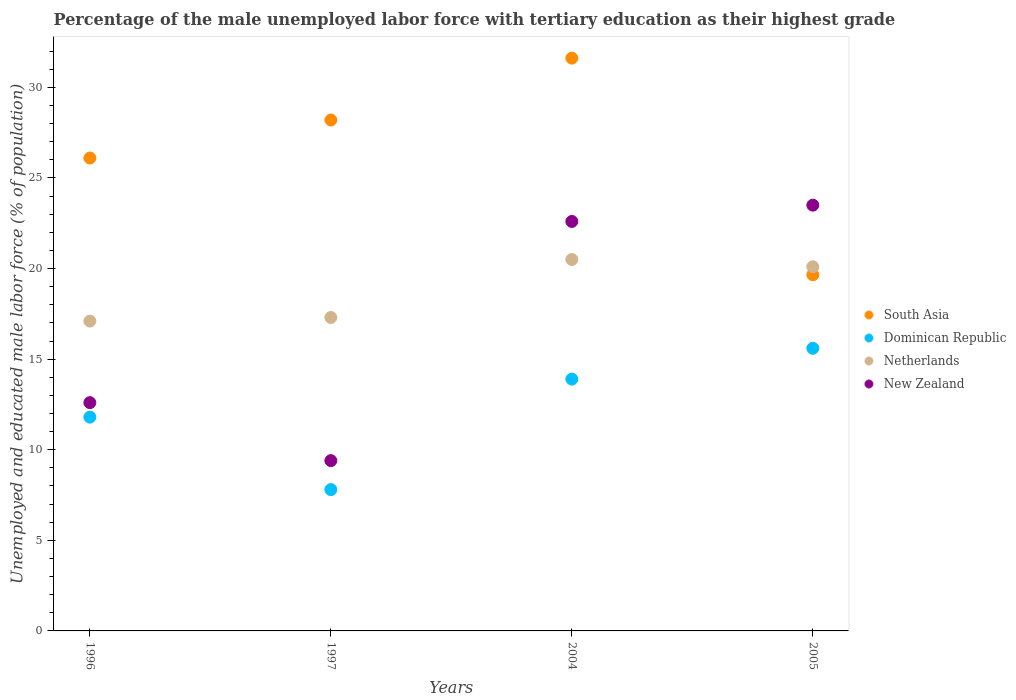Is the number of dotlines equal to the number of legend labels?
Keep it short and to the point. Yes. What is the percentage of the unemployed male labor force with tertiary education in Netherlands in 1997?
Keep it short and to the point. 17.3. Across all years, what is the maximum percentage of the unemployed male labor force with tertiary education in New Zealand?
Keep it short and to the point. 23.5. Across all years, what is the minimum percentage of the unemployed male labor force with tertiary education in South Asia?
Your answer should be very brief. 19.66. What is the total percentage of the unemployed male labor force with tertiary education in South Asia in the graph?
Offer a terse response. 105.57. What is the difference between the percentage of the unemployed male labor force with tertiary education in New Zealand in 2004 and that in 2005?
Ensure brevity in your answer.  -0.9. What is the difference between the percentage of the unemployed male labor force with tertiary education in South Asia in 1997 and the percentage of the unemployed male labor force with tertiary education in Dominican Republic in 2005?
Ensure brevity in your answer.  12.6. What is the average percentage of the unemployed male labor force with tertiary education in Netherlands per year?
Make the answer very short. 18.75. In the year 2004, what is the difference between the percentage of the unemployed male labor force with tertiary education in Netherlands and percentage of the unemployed male labor force with tertiary education in South Asia?
Your answer should be compact. -11.11. In how many years, is the percentage of the unemployed male labor force with tertiary education in Dominican Republic greater than 18 %?
Provide a succinct answer. 0. What is the ratio of the percentage of the unemployed male labor force with tertiary education in Netherlands in 1996 to that in 1997?
Keep it short and to the point. 0.99. Is the percentage of the unemployed male labor force with tertiary education in Netherlands in 1996 less than that in 2004?
Provide a short and direct response. Yes. What is the difference between the highest and the second highest percentage of the unemployed male labor force with tertiary education in New Zealand?
Make the answer very short. 0.9. What is the difference between the highest and the lowest percentage of the unemployed male labor force with tertiary education in Netherlands?
Make the answer very short. 3.4. In how many years, is the percentage of the unemployed male labor force with tertiary education in South Asia greater than the average percentage of the unemployed male labor force with tertiary education in South Asia taken over all years?
Offer a terse response. 2. Is the sum of the percentage of the unemployed male labor force with tertiary education in Netherlands in 1996 and 2004 greater than the maximum percentage of the unemployed male labor force with tertiary education in New Zealand across all years?
Keep it short and to the point. Yes. Does the percentage of the unemployed male labor force with tertiary education in South Asia monotonically increase over the years?
Your response must be concise. No. Is the percentage of the unemployed male labor force with tertiary education in South Asia strictly less than the percentage of the unemployed male labor force with tertiary education in Dominican Republic over the years?
Give a very brief answer. No. How many years are there in the graph?
Give a very brief answer. 4. What is the difference between two consecutive major ticks on the Y-axis?
Offer a terse response. 5. Does the graph contain any zero values?
Ensure brevity in your answer.  No. Does the graph contain grids?
Provide a succinct answer. No. Where does the legend appear in the graph?
Provide a succinct answer. Center right. How many legend labels are there?
Make the answer very short. 4. What is the title of the graph?
Provide a succinct answer. Percentage of the male unemployed labor force with tertiary education as their highest grade. Does "Mauritius" appear as one of the legend labels in the graph?
Give a very brief answer. No. What is the label or title of the X-axis?
Offer a terse response. Years. What is the label or title of the Y-axis?
Give a very brief answer. Unemployed and educated male labor force (% of population). What is the Unemployed and educated male labor force (% of population) in South Asia in 1996?
Ensure brevity in your answer.  26.1. What is the Unemployed and educated male labor force (% of population) in Dominican Republic in 1996?
Your answer should be compact. 11.8. What is the Unemployed and educated male labor force (% of population) of Netherlands in 1996?
Your answer should be very brief. 17.1. What is the Unemployed and educated male labor force (% of population) of New Zealand in 1996?
Offer a very short reply. 12.6. What is the Unemployed and educated male labor force (% of population) of South Asia in 1997?
Keep it short and to the point. 28.2. What is the Unemployed and educated male labor force (% of population) of Dominican Republic in 1997?
Ensure brevity in your answer.  7.8. What is the Unemployed and educated male labor force (% of population) in Netherlands in 1997?
Offer a very short reply. 17.3. What is the Unemployed and educated male labor force (% of population) in New Zealand in 1997?
Ensure brevity in your answer.  9.4. What is the Unemployed and educated male labor force (% of population) of South Asia in 2004?
Provide a succinct answer. 31.61. What is the Unemployed and educated male labor force (% of population) of Dominican Republic in 2004?
Provide a succinct answer. 13.9. What is the Unemployed and educated male labor force (% of population) in Netherlands in 2004?
Keep it short and to the point. 20.5. What is the Unemployed and educated male labor force (% of population) of New Zealand in 2004?
Ensure brevity in your answer.  22.6. What is the Unemployed and educated male labor force (% of population) in South Asia in 2005?
Ensure brevity in your answer.  19.66. What is the Unemployed and educated male labor force (% of population) in Dominican Republic in 2005?
Ensure brevity in your answer.  15.6. What is the Unemployed and educated male labor force (% of population) in Netherlands in 2005?
Make the answer very short. 20.1. Across all years, what is the maximum Unemployed and educated male labor force (% of population) in South Asia?
Give a very brief answer. 31.61. Across all years, what is the maximum Unemployed and educated male labor force (% of population) in Dominican Republic?
Ensure brevity in your answer.  15.6. Across all years, what is the maximum Unemployed and educated male labor force (% of population) of Netherlands?
Your response must be concise. 20.5. Across all years, what is the maximum Unemployed and educated male labor force (% of population) of New Zealand?
Offer a terse response. 23.5. Across all years, what is the minimum Unemployed and educated male labor force (% of population) of South Asia?
Ensure brevity in your answer.  19.66. Across all years, what is the minimum Unemployed and educated male labor force (% of population) in Dominican Republic?
Your answer should be compact. 7.8. Across all years, what is the minimum Unemployed and educated male labor force (% of population) in Netherlands?
Your answer should be compact. 17.1. Across all years, what is the minimum Unemployed and educated male labor force (% of population) in New Zealand?
Provide a succinct answer. 9.4. What is the total Unemployed and educated male labor force (% of population) of South Asia in the graph?
Make the answer very short. 105.57. What is the total Unemployed and educated male labor force (% of population) in Dominican Republic in the graph?
Your response must be concise. 49.1. What is the total Unemployed and educated male labor force (% of population) in New Zealand in the graph?
Provide a short and direct response. 68.1. What is the difference between the Unemployed and educated male labor force (% of population) of South Asia in 1996 and that in 1997?
Offer a very short reply. -2.1. What is the difference between the Unemployed and educated male labor force (% of population) of Dominican Republic in 1996 and that in 1997?
Give a very brief answer. 4. What is the difference between the Unemployed and educated male labor force (% of population) of Netherlands in 1996 and that in 1997?
Make the answer very short. -0.2. What is the difference between the Unemployed and educated male labor force (% of population) in New Zealand in 1996 and that in 1997?
Offer a terse response. 3.2. What is the difference between the Unemployed and educated male labor force (% of population) in South Asia in 1996 and that in 2004?
Your answer should be very brief. -5.51. What is the difference between the Unemployed and educated male labor force (% of population) of Dominican Republic in 1996 and that in 2004?
Offer a terse response. -2.1. What is the difference between the Unemployed and educated male labor force (% of population) of Netherlands in 1996 and that in 2004?
Offer a terse response. -3.4. What is the difference between the Unemployed and educated male labor force (% of population) of New Zealand in 1996 and that in 2004?
Your response must be concise. -10. What is the difference between the Unemployed and educated male labor force (% of population) of South Asia in 1996 and that in 2005?
Provide a short and direct response. 6.44. What is the difference between the Unemployed and educated male labor force (% of population) of Dominican Republic in 1996 and that in 2005?
Ensure brevity in your answer.  -3.8. What is the difference between the Unemployed and educated male labor force (% of population) of South Asia in 1997 and that in 2004?
Provide a short and direct response. -3.41. What is the difference between the Unemployed and educated male labor force (% of population) in South Asia in 1997 and that in 2005?
Your response must be concise. 8.54. What is the difference between the Unemployed and educated male labor force (% of population) in Dominican Republic in 1997 and that in 2005?
Ensure brevity in your answer.  -7.8. What is the difference between the Unemployed and educated male labor force (% of population) in Netherlands in 1997 and that in 2005?
Keep it short and to the point. -2.8. What is the difference between the Unemployed and educated male labor force (% of population) in New Zealand in 1997 and that in 2005?
Your response must be concise. -14.1. What is the difference between the Unemployed and educated male labor force (% of population) in South Asia in 2004 and that in 2005?
Offer a very short reply. 11.96. What is the difference between the Unemployed and educated male labor force (% of population) of New Zealand in 2004 and that in 2005?
Your response must be concise. -0.9. What is the difference between the Unemployed and educated male labor force (% of population) in South Asia in 1996 and the Unemployed and educated male labor force (% of population) in Dominican Republic in 1997?
Keep it short and to the point. 18.3. What is the difference between the Unemployed and educated male labor force (% of population) of South Asia in 1996 and the Unemployed and educated male labor force (% of population) of Netherlands in 1997?
Your response must be concise. 8.8. What is the difference between the Unemployed and educated male labor force (% of population) of South Asia in 1996 and the Unemployed and educated male labor force (% of population) of New Zealand in 1997?
Offer a terse response. 16.7. What is the difference between the Unemployed and educated male labor force (% of population) of Dominican Republic in 1996 and the Unemployed and educated male labor force (% of population) of New Zealand in 1997?
Provide a short and direct response. 2.4. What is the difference between the Unemployed and educated male labor force (% of population) of Netherlands in 1996 and the Unemployed and educated male labor force (% of population) of New Zealand in 1997?
Your answer should be compact. 7.7. What is the difference between the Unemployed and educated male labor force (% of population) of South Asia in 1996 and the Unemployed and educated male labor force (% of population) of Dominican Republic in 2004?
Make the answer very short. 12.2. What is the difference between the Unemployed and educated male labor force (% of population) in South Asia in 1996 and the Unemployed and educated male labor force (% of population) in Netherlands in 2004?
Ensure brevity in your answer.  5.6. What is the difference between the Unemployed and educated male labor force (% of population) in South Asia in 1996 and the Unemployed and educated male labor force (% of population) in New Zealand in 2004?
Give a very brief answer. 3.5. What is the difference between the Unemployed and educated male labor force (% of population) of Dominican Republic in 1996 and the Unemployed and educated male labor force (% of population) of New Zealand in 2004?
Give a very brief answer. -10.8. What is the difference between the Unemployed and educated male labor force (% of population) of Netherlands in 1996 and the Unemployed and educated male labor force (% of population) of New Zealand in 2004?
Offer a terse response. -5.5. What is the difference between the Unemployed and educated male labor force (% of population) in South Asia in 1996 and the Unemployed and educated male labor force (% of population) in Dominican Republic in 2005?
Offer a terse response. 10.5. What is the difference between the Unemployed and educated male labor force (% of population) in South Asia in 1996 and the Unemployed and educated male labor force (% of population) in Netherlands in 2005?
Ensure brevity in your answer.  6. What is the difference between the Unemployed and educated male labor force (% of population) of South Asia in 1996 and the Unemployed and educated male labor force (% of population) of New Zealand in 2005?
Provide a succinct answer. 2.6. What is the difference between the Unemployed and educated male labor force (% of population) in Dominican Republic in 1996 and the Unemployed and educated male labor force (% of population) in New Zealand in 2005?
Your answer should be very brief. -11.7. What is the difference between the Unemployed and educated male labor force (% of population) in Netherlands in 1996 and the Unemployed and educated male labor force (% of population) in New Zealand in 2005?
Your response must be concise. -6.4. What is the difference between the Unemployed and educated male labor force (% of population) in South Asia in 1997 and the Unemployed and educated male labor force (% of population) in Netherlands in 2004?
Offer a terse response. 7.7. What is the difference between the Unemployed and educated male labor force (% of population) of South Asia in 1997 and the Unemployed and educated male labor force (% of population) of New Zealand in 2004?
Your answer should be very brief. 5.6. What is the difference between the Unemployed and educated male labor force (% of population) of Dominican Republic in 1997 and the Unemployed and educated male labor force (% of population) of New Zealand in 2004?
Provide a short and direct response. -14.8. What is the difference between the Unemployed and educated male labor force (% of population) in Netherlands in 1997 and the Unemployed and educated male labor force (% of population) in New Zealand in 2004?
Keep it short and to the point. -5.3. What is the difference between the Unemployed and educated male labor force (% of population) in South Asia in 1997 and the Unemployed and educated male labor force (% of population) in Dominican Republic in 2005?
Provide a succinct answer. 12.6. What is the difference between the Unemployed and educated male labor force (% of population) in Dominican Republic in 1997 and the Unemployed and educated male labor force (% of population) in New Zealand in 2005?
Your answer should be very brief. -15.7. What is the difference between the Unemployed and educated male labor force (% of population) in Netherlands in 1997 and the Unemployed and educated male labor force (% of population) in New Zealand in 2005?
Provide a succinct answer. -6.2. What is the difference between the Unemployed and educated male labor force (% of population) in South Asia in 2004 and the Unemployed and educated male labor force (% of population) in Dominican Republic in 2005?
Provide a short and direct response. 16.01. What is the difference between the Unemployed and educated male labor force (% of population) of South Asia in 2004 and the Unemployed and educated male labor force (% of population) of Netherlands in 2005?
Ensure brevity in your answer.  11.51. What is the difference between the Unemployed and educated male labor force (% of population) in South Asia in 2004 and the Unemployed and educated male labor force (% of population) in New Zealand in 2005?
Offer a very short reply. 8.11. What is the difference between the Unemployed and educated male labor force (% of population) of Dominican Republic in 2004 and the Unemployed and educated male labor force (% of population) of Netherlands in 2005?
Ensure brevity in your answer.  -6.2. What is the difference between the Unemployed and educated male labor force (% of population) in Dominican Republic in 2004 and the Unemployed and educated male labor force (% of population) in New Zealand in 2005?
Your answer should be very brief. -9.6. What is the difference between the Unemployed and educated male labor force (% of population) of Netherlands in 2004 and the Unemployed and educated male labor force (% of population) of New Zealand in 2005?
Your answer should be compact. -3. What is the average Unemployed and educated male labor force (% of population) of South Asia per year?
Make the answer very short. 26.39. What is the average Unemployed and educated male labor force (% of population) in Dominican Republic per year?
Keep it short and to the point. 12.28. What is the average Unemployed and educated male labor force (% of population) in Netherlands per year?
Your answer should be very brief. 18.75. What is the average Unemployed and educated male labor force (% of population) in New Zealand per year?
Your response must be concise. 17.02. In the year 1996, what is the difference between the Unemployed and educated male labor force (% of population) of South Asia and Unemployed and educated male labor force (% of population) of Dominican Republic?
Ensure brevity in your answer.  14.3. In the year 1996, what is the difference between the Unemployed and educated male labor force (% of population) in South Asia and Unemployed and educated male labor force (% of population) in Netherlands?
Keep it short and to the point. 9. In the year 1996, what is the difference between the Unemployed and educated male labor force (% of population) of South Asia and Unemployed and educated male labor force (% of population) of New Zealand?
Your response must be concise. 13.5. In the year 1996, what is the difference between the Unemployed and educated male labor force (% of population) in Dominican Republic and Unemployed and educated male labor force (% of population) in Netherlands?
Your answer should be compact. -5.3. In the year 1996, what is the difference between the Unemployed and educated male labor force (% of population) of Netherlands and Unemployed and educated male labor force (% of population) of New Zealand?
Your answer should be very brief. 4.5. In the year 1997, what is the difference between the Unemployed and educated male labor force (% of population) in South Asia and Unemployed and educated male labor force (% of population) in Dominican Republic?
Your answer should be compact. 20.4. In the year 1997, what is the difference between the Unemployed and educated male labor force (% of population) of Dominican Republic and Unemployed and educated male labor force (% of population) of New Zealand?
Your answer should be very brief. -1.6. In the year 2004, what is the difference between the Unemployed and educated male labor force (% of population) of South Asia and Unemployed and educated male labor force (% of population) of Dominican Republic?
Your answer should be compact. 17.71. In the year 2004, what is the difference between the Unemployed and educated male labor force (% of population) of South Asia and Unemployed and educated male labor force (% of population) of Netherlands?
Keep it short and to the point. 11.11. In the year 2004, what is the difference between the Unemployed and educated male labor force (% of population) in South Asia and Unemployed and educated male labor force (% of population) in New Zealand?
Provide a succinct answer. 9.01. In the year 2005, what is the difference between the Unemployed and educated male labor force (% of population) in South Asia and Unemployed and educated male labor force (% of population) in Dominican Republic?
Your response must be concise. 4.06. In the year 2005, what is the difference between the Unemployed and educated male labor force (% of population) in South Asia and Unemployed and educated male labor force (% of population) in Netherlands?
Offer a very short reply. -0.44. In the year 2005, what is the difference between the Unemployed and educated male labor force (% of population) of South Asia and Unemployed and educated male labor force (% of population) of New Zealand?
Offer a very short reply. -3.84. In the year 2005, what is the difference between the Unemployed and educated male labor force (% of population) in Dominican Republic and Unemployed and educated male labor force (% of population) in Netherlands?
Ensure brevity in your answer.  -4.5. What is the ratio of the Unemployed and educated male labor force (% of population) in South Asia in 1996 to that in 1997?
Give a very brief answer. 0.93. What is the ratio of the Unemployed and educated male labor force (% of population) in Dominican Republic in 1996 to that in 1997?
Ensure brevity in your answer.  1.51. What is the ratio of the Unemployed and educated male labor force (% of population) in Netherlands in 1996 to that in 1997?
Ensure brevity in your answer.  0.99. What is the ratio of the Unemployed and educated male labor force (% of population) in New Zealand in 1996 to that in 1997?
Ensure brevity in your answer.  1.34. What is the ratio of the Unemployed and educated male labor force (% of population) of South Asia in 1996 to that in 2004?
Provide a succinct answer. 0.83. What is the ratio of the Unemployed and educated male labor force (% of population) in Dominican Republic in 1996 to that in 2004?
Offer a very short reply. 0.85. What is the ratio of the Unemployed and educated male labor force (% of population) of Netherlands in 1996 to that in 2004?
Your response must be concise. 0.83. What is the ratio of the Unemployed and educated male labor force (% of population) of New Zealand in 1996 to that in 2004?
Your answer should be very brief. 0.56. What is the ratio of the Unemployed and educated male labor force (% of population) of South Asia in 1996 to that in 2005?
Your response must be concise. 1.33. What is the ratio of the Unemployed and educated male labor force (% of population) of Dominican Republic in 1996 to that in 2005?
Ensure brevity in your answer.  0.76. What is the ratio of the Unemployed and educated male labor force (% of population) in Netherlands in 1996 to that in 2005?
Your response must be concise. 0.85. What is the ratio of the Unemployed and educated male labor force (% of population) in New Zealand in 1996 to that in 2005?
Make the answer very short. 0.54. What is the ratio of the Unemployed and educated male labor force (% of population) in South Asia in 1997 to that in 2004?
Provide a succinct answer. 0.89. What is the ratio of the Unemployed and educated male labor force (% of population) of Dominican Republic in 1997 to that in 2004?
Your answer should be very brief. 0.56. What is the ratio of the Unemployed and educated male labor force (% of population) of Netherlands in 1997 to that in 2004?
Provide a short and direct response. 0.84. What is the ratio of the Unemployed and educated male labor force (% of population) of New Zealand in 1997 to that in 2004?
Provide a short and direct response. 0.42. What is the ratio of the Unemployed and educated male labor force (% of population) of South Asia in 1997 to that in 2005?
Give a very brief answer. 1.43. What is the ratio of the Unemployed and educated male labor force (% of population) of Netherlands in 1997 to that in 2005?
Keep it short and to the point. 0.86. What is the ratio of the Unemployed and educated male labor force (% of population) in New Zealand in 1997 to that in 2005?
Provide a short and direct response. 0.4. What is the ratio of the Unemployed and educated male labor force (% of population) of South Asia in 2004 to that in 2005?
Give a very brief answer. 1.61. What is the ratio of the Unemployed and educated male labor force (% of population) of Dominican Republic in 2004 to that in 2005?
Keep it short and to the point. 0.89. What is the ratio of the Unemployed and educated male labor force (% of population) in Netherlands in 2004 to that in 2005?
Provide a succinct answer. 1.02. What is the ratio of the Unemployed and educated male labor force (% of population) of New Zealand in 2004 to that in 2005?
Provide a short and direct response. 0.96. What is the difference between the highest and the second highest Unemployed and educated male labor force (% of population) of South Asia?
Make the answer very short. 3.41. What is the difference between the highest and the second highest Unemployed and educated male labor force (% of population) of Dominican Republic?
Provide a short and direct response. 1.7. What is the difference between the highest and the second highest Unemployed and educated male labor force (% of population) of Netherlands?
Provide a short and direct response. 0.4. What is the difference between the highest and the lowest Unemployed and educated male labor force (% of population) in South Asia?
Provide a short and direct response. 11.96. What is the difference between the highest and the lowest Unemployed and educated male labor force (% of population) of Dominican Republic?
Your response must be concise. 7.8. What is the difference between the highest and the lowest Unemployed and educated male labor force (% of population) in Netherlands?
Provide a short and direct response. 3.4. 